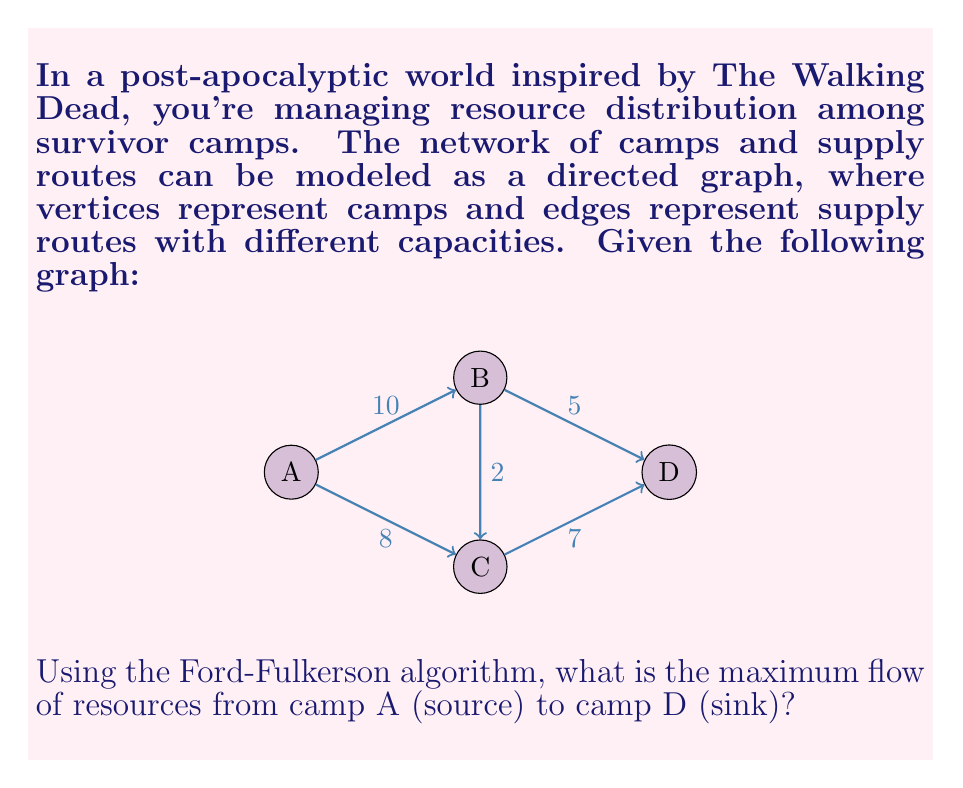Could you help me with this problem? To solve this problem using the Ford-Fulkerson algorithm, we'll follow these steps:

1) Initialize the flow on all edges to 0.

2) Find an augmenting path from A to D. We'll use depth-first search (DFS).

3) Augment the flow along this path by the minimum capacity on the path.

4) Repeat steps 2-3 until no augmenting path exists.

Let's go through the iterations:

Iteration 1:
Path: A -> B -> D
Min capacity: min(10, 5) = 5
Flow: 5
Residual graph:
A -> B: 5/10
B -> D: 5/5
Total flow: 5

Iteration 2:
Path: A -> C -> D
Min capacity: min(8, 7) = 7
Flow: 7
Residual graph:
A -> B: 5/10
A -> C: 7/8
B -> D: 5/5
C -> D: 7/7
Total flow: 12

Iteration 3:
Path: A -> B -> C -> D
Min capacity: min(5, 2, 0) = 0
No more augmenting paths exist.

The maximum flow is the sum of all flows into D, which is 5 + 7 = 12.

This result means that the maximum amount of resources that can be distributed from camp A to camp D per unit time is 12 units.
Answer: 12 units 